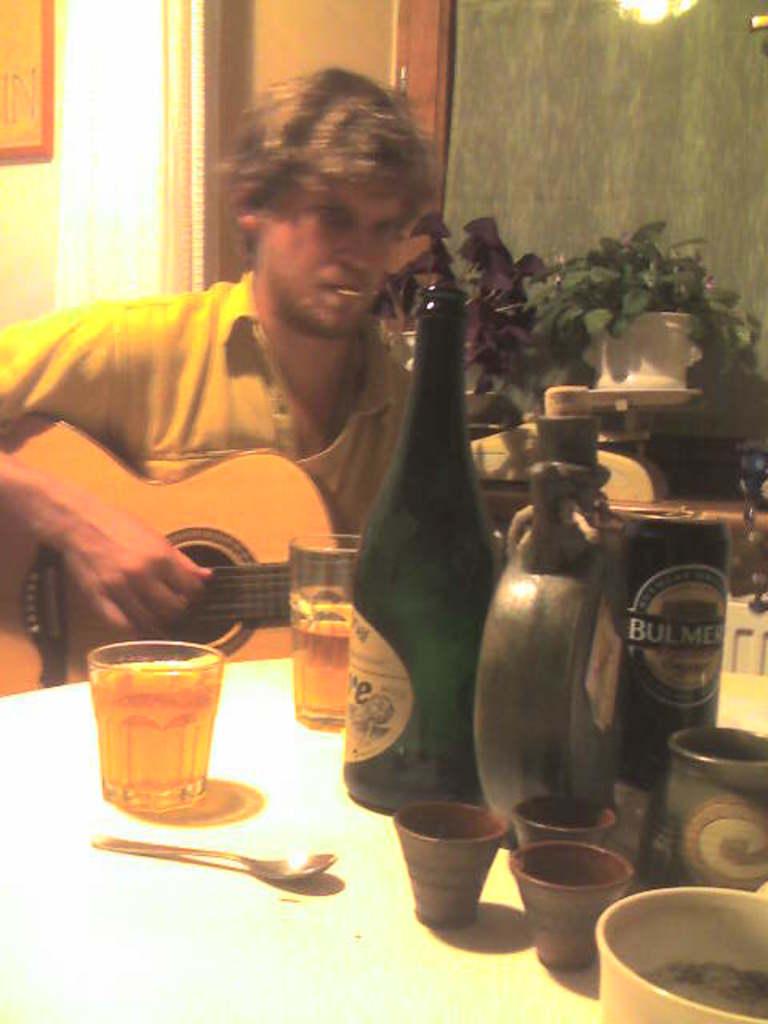What type of beverage is seen here?
Provide a succinct answer. Bulmer. What is the brand of beer in the can?
Provide a succinct answer. Bulmer. 